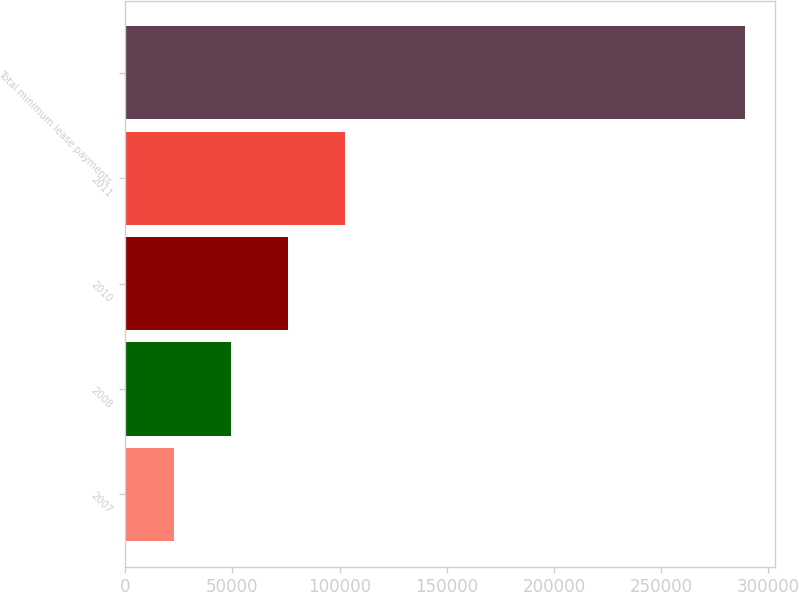<chart> <loc_0><loc_0><loc_500><loc_500><bar_chart><fcel>2007<fcel>2008<fcel>2010<fcel>2011<fcel>Total minimum lease payments<nl><fcel>22718<fcel>49328.5<fcel>75939<fcel>102550<fcel>288823<nl></chart> 